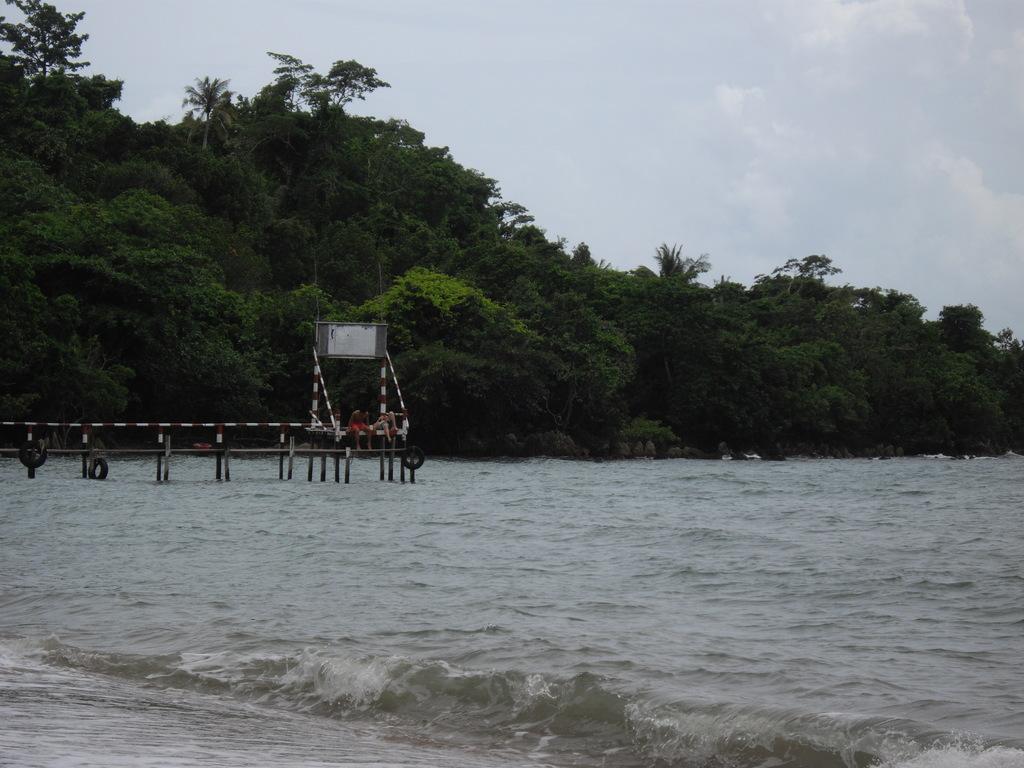Describe this image in one or two sentences. In this picture there is water at the bottom side of the image and there is a dock on the left side of the image, on which there are two people and there are trees in the background area of the image. 